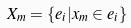Convert formula to latex. <formula><loc_0><loc_0><loc_500><loc_500>X _ { m } = \{ e _ { i } | x _ { m } \in e _ { i } \}</formula> 